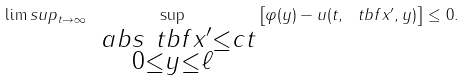<formula> <loc_0><loc_0><loc_500><loc_500>\lim s u p _ { t \to \infty } \sup _ { \substack { \ a b s { \ t b f { x } ^ { \prime } } \leq c t \\ 0 \leq y \leq \ell } } \left [ \varphi ( y ) - u ( t , \ t b f { x } ^ { \prime } , y ) \right ] \leq 0 .</formula> 